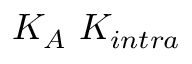Convert formula to latex. <formula><loc_0><loc_0><loc_500><loc_500>K _ { A } \ K _ { i n t r a }</formula> 